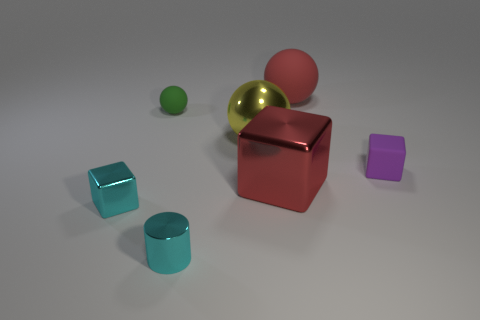Add 2 shiny blocks. How many objects exist? 9 Subtract all spheres. How many objects are left? 4 Subtract all big yellow things. Subtract all red matte objects. How many objects are left? 5 Add 7 tiny metallic cylinders. How many tiny metallic cylinders are left? 8 Add 5 green cylinders. How many green cylinders exist? 5 Subtract 1 red cubes. How many objects are left? 6 